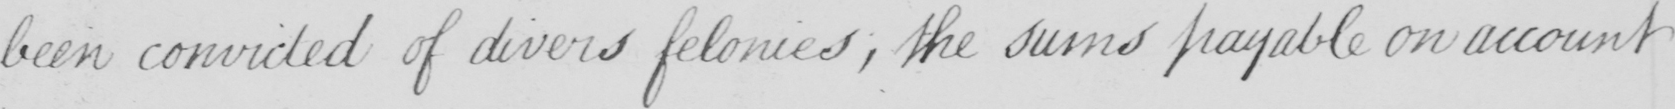What is written in this line of handwriting? been convicted of divers felonies , the sums payable on account 